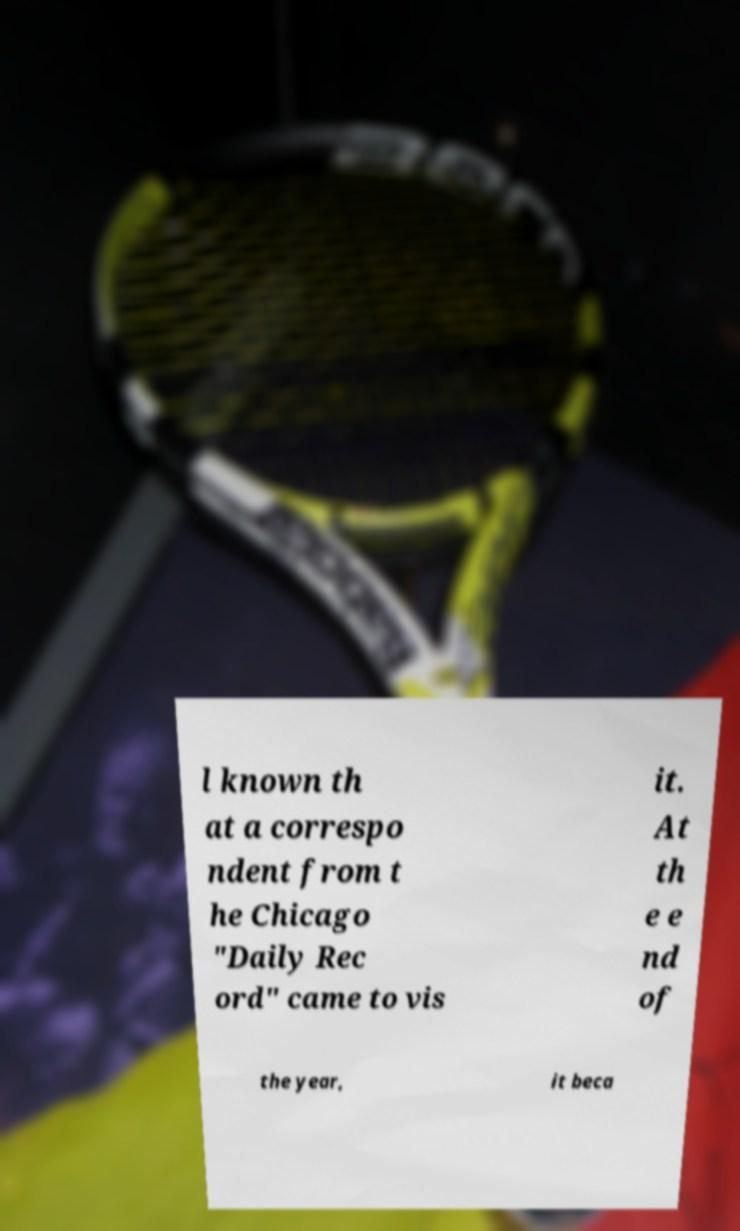What messages or text are displayed in this image? I need them in a readable, typed format. l known th at a correspo ndent from t he Chicago "Daily Rec ord" came to vis it. At th e e nd of the year, it beca 